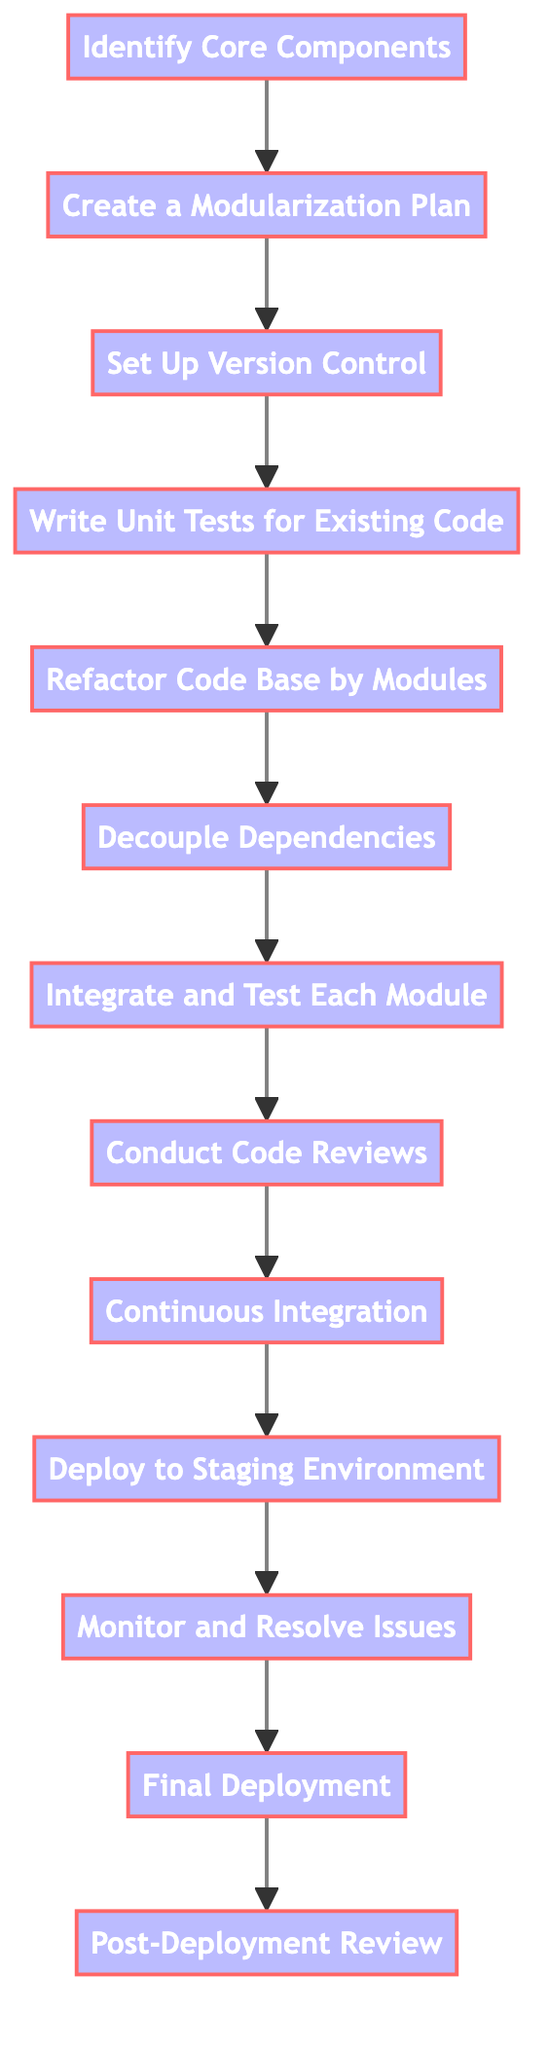What is the first step in the refactoring process? The first step shown in the diagram is "Identify Core Components", which is the starting point of the sequence.
Answer: Identify Core Components How many total processes are present in the diagram? By counting the elements in the diagram, we see there are a total of thirteen distinct processes listed.
Answer: 13 What process follows "Write Unit Tests for Existing Code"? After "Write Unit Tests for Existing Code", the next process in the flow is "Refactor Code Base by Modules", indicating the direct transition from testing to refactoring.
Answer: Refactor Code Base by Modules Which process comes before "Integrate and Test Each Module"? The process preceding "Integrate and Test Each Module" is "Decouple Dependencies", meaning dependencies must be handled before integration can occur.
Answer: Decouple Dependencies What is the final process listed in the flowchart? The last step in the diagram is "Post-Deployment Review", which occurs after all deployment actions are completed.
Answer: Post-Deployment Review Which two processes are directly linked by the arrow after "Conduct Code Reviews"? The two processes linked directly after "Conduct Code Reviews" are "Continuous Integration", indicating that review leads to establishing continuous integration practices.
Answer: Continuous Integration What is the purpose of setting up version control according to the diagram? The diagram states that the purpose of "Set Up Version Control" is to track changes and allow for rollback if needed, ensuring the team's work is safeguarded.
Answer: Track changes and allow for rollback Which process involves testing the refactored code? The process that specifically involves testing the refactored code is "Integrate and Test Each Module", indicating that module testing is a crucial step in the flow.
Answer: Integrate and Test Each Module What comes immediately after deploying to the staging environment? Following the "Deploy to Staging Environment", the next step is to "Monitor and Resolve Issues", suggesting that monitoring is essential after deployment.
Answer: Monitor and Resolve Issues 